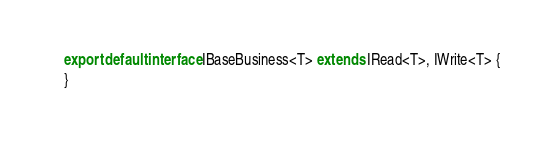<code> <loc_0><loc_0><loc_500><loc_500><_TypeScript_>
export default interface IBaseBusiness<T> extends IRead<T>, IWrite<T> {
}
</code> 